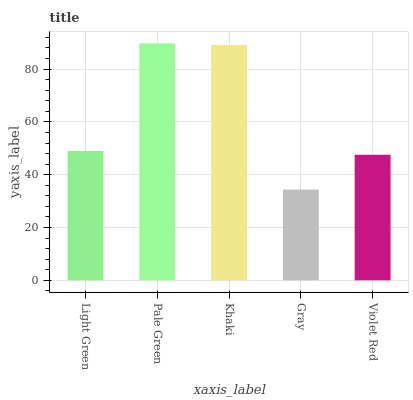Is Gray the minimum?
Answer yes or no. Yes. Is Pale Green the maximum?
Answer yes or no. Yes. Is Khaki the minimum?
Answer yes or no. No. Is Khaki the maximum?
Answer yes or no. No. Is Pale Green greater than Khaki?
Answer yes or no. Yes. Is Khaki less than Pale Green?
Answer yes or no. Yes. Is Khaki greater than Pale Green?
Answer yes or no. No. Is Pale Green less than Khaki?
Answer yes or no. No. Is Light Green the high median?
Answer yes or no. Yes. Is Light Green the low median?
Answer yes or no. Yes. Is Violet Red the high median?
Answer yes or no. No. Is Pale Green the low median?
Answer yes or no. No. 